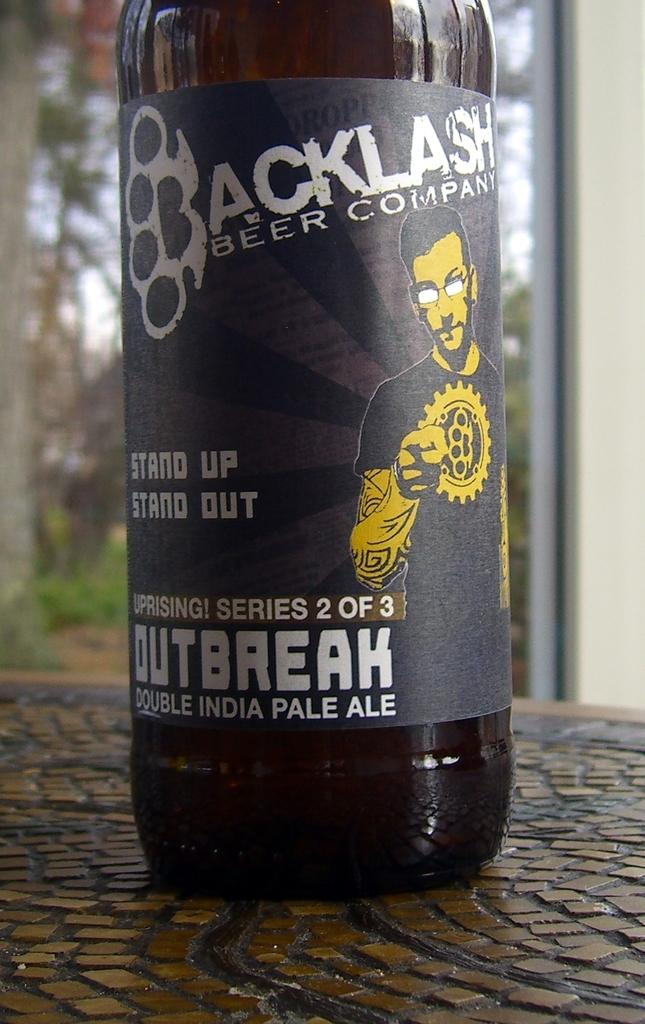<image>
Relay a brief, clear account of the picture shown. A bottle of beer from the Backlash Beer Company. 